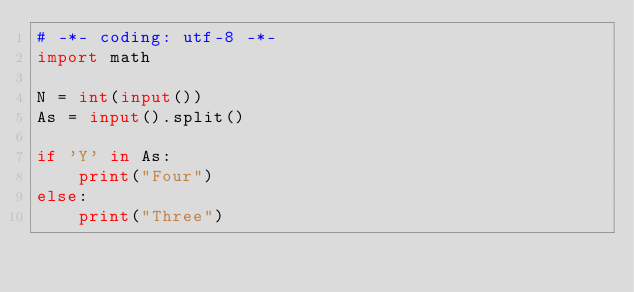<code> <loc_0><loc_0><loc_500><loc_500><_Python_># -*- coding: utf-8 -*-
import math

N = int(input())
As = input().split()

if 'Y' in As:
    print("Four")
else:
    print("Three")
</code> 